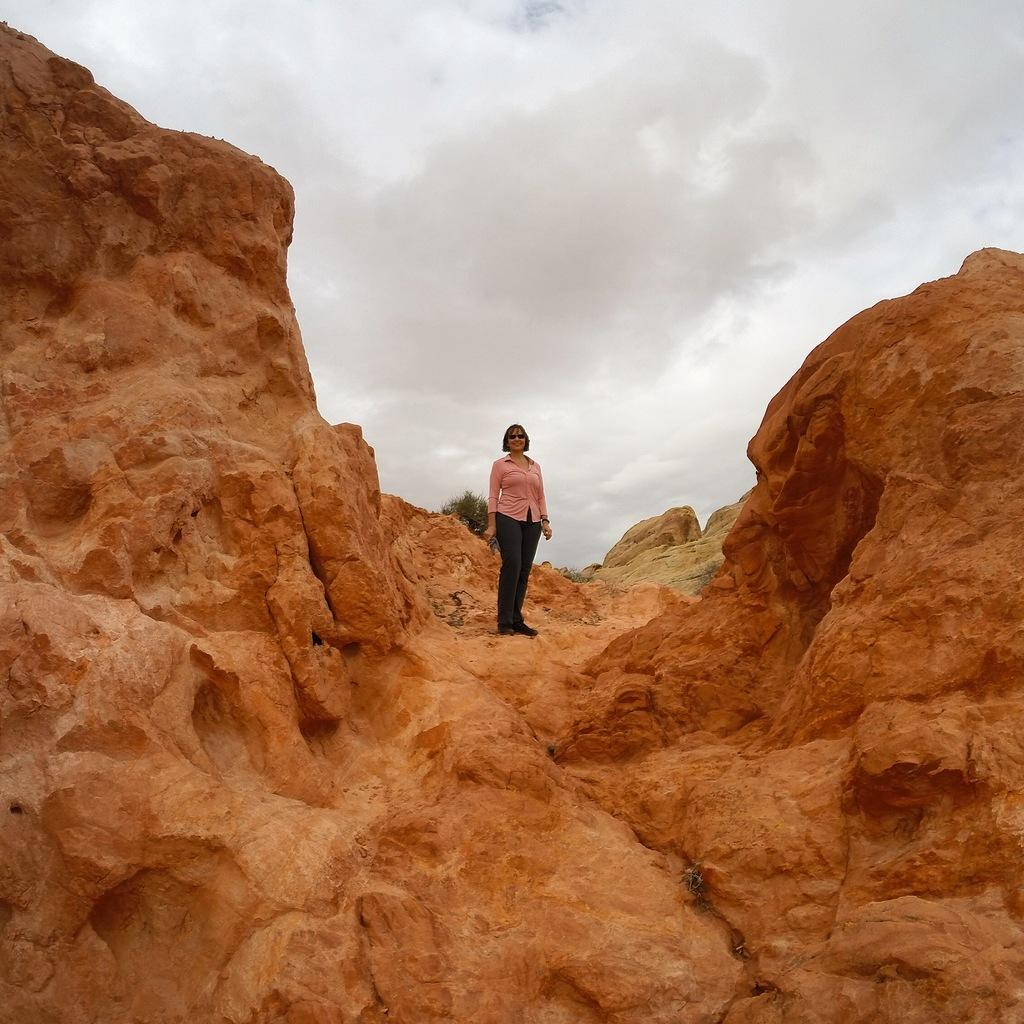What is the woman doing in the image? The woman is standing on a mountain. What can be seen in the background of the image? The sky is visible in the background of the image. How much debt does the woman have in the image? There is no information about the woman's debt in the image. What type of sail is being used by the woman in the image? The woman is not sailing in the image; she is standing on a mountain. Is there an oven visible in the image? There is no oven present in the image. 